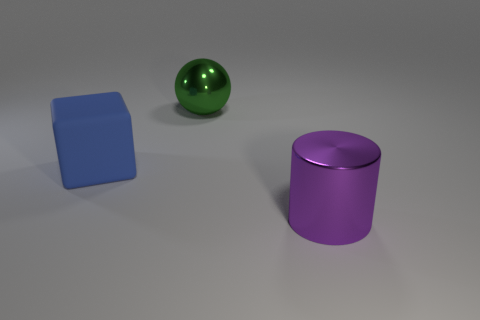Add 2 big red rubber balls. How many objects exist? 5 Subtract all spheres. How many objects are left? 2 Add 3 green balls. How many green balls are left? 4 Add 3 blue shiny balls. How many blue shiny balls exist? 3 Subtract 1 green spheres. How many objects are left? 2 Subtract all blue things. Subtract all rubber objects. How many objects are left? 1 